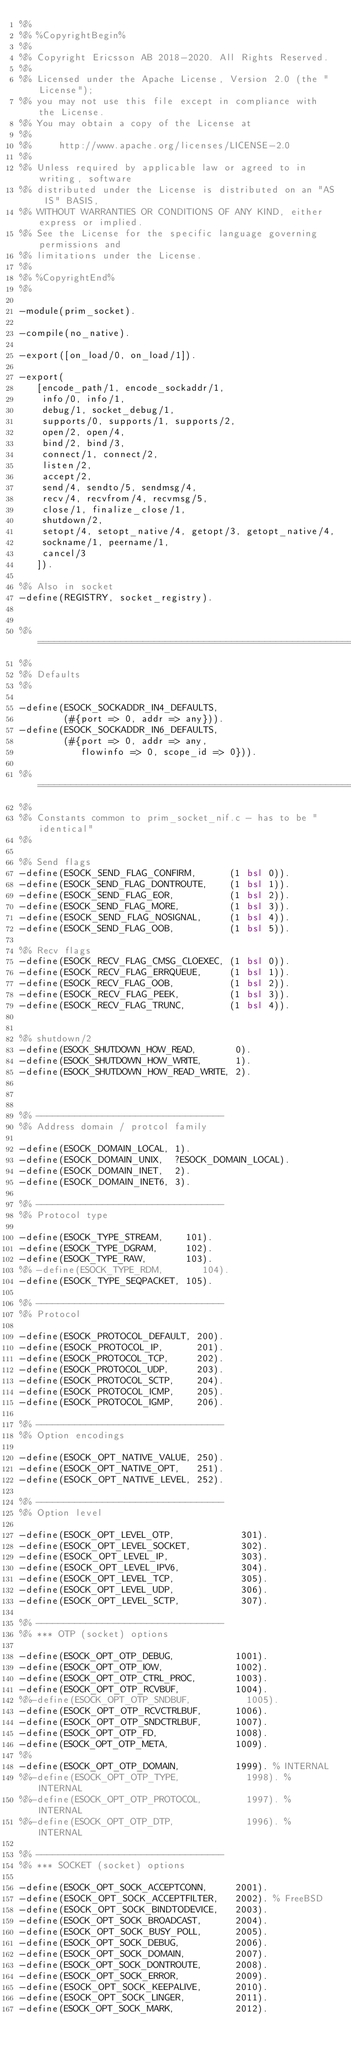Convert code to text. <code><loc_0><loc_0><loc_500><loc_500><_Erlang_>%%
%% %CopyrightBegin%
%%
%% Copyright Ericsson AB 2018-2020. All Rights Reserved.
%%
%% Licensed under the Apache License, Version 2.0 (the "License");
%% you may not use this file except in compliance with the License.
%% You may obtain a copy of the License at
%%
%%     http://www.apache.org/licenses/LICENSE-2.0
%%
%% Unless required by applicable law or agreed to in writing, software
%% distributed under the License is distributed on an "AS IS" BASIS,
%% WITHOUT WARRANTIES OR CONDITIONS OF ANY KIND, either express or implied.
%% See the License for the specific language governing permissions and
%% limitations under the License.
%%
%% %CopyrightEnd%
%%

-module(prim_socket).

-compile(no_native).

-export([on_load/0, on_load/1]).

-export(
   [encode_path/1, encode_sockaddr/1,
    info/0, info/1,
    debug/1, socket_debug/1,
    supports/0, supports/1, supports/2,
    open/2, open/4,
    bind/2, bind/3,
    connect/1, connect/2,
    listen/2,
    accept/2,
    send/4, sendto/5, sendmsg/4,
    recv/4, recvfrom/4, recvmsg/5,
    close/1, finalize_close/1,
    shutdown/2,
    setopt/4, setopt_native/4, getopt/3, getopt_native/4,
    sockname/1, peername/1,
    cancel/3
   ]).

%% Also in socket
-define(REGISTRY, socket_registry).


%% ===========================================================================
%%
%% Defaults
%%

-define(ESOCK_SOCKADDR_IN4_DEFAULTS,
        (#{port => 0, addr => any})).
-define(ESOCK_SOCKADDR_IN6_DEFAULTS,
        (#{port => 0, addr => any,
           flowinfo => 0, scope_id => 0})).

%% ===========================================================================
%%
%% Constants common to prim_socket_nif.c - has to be "identical"
%%

%% Send flags
-define(ESOCK_SEND_FLAG_CONFIRM,      (1 bsl 0)).
-define(ESOCK_SEND_FLAG_DONTROUTE,    (1 bsl 1)).
-define(ESOCK_SEND_FLAG_EOR,          (1 bsl 2)).
-define(ESOCK_SEND_FLAG_MORE,         (1 bsl 3)).
-define(ESOCK_SEND_FLAG_NOSIGNAL,     (1 bsl 4)).
-define(ESOCK_SEND_FLAG_OOB,          (1 bsl 5)).

%% Recv flags
-define(ESOCK_RECV_FLAG_CMSG_CLOEXEC, (1 bsl 0)).
-define(ESOCK_RECV_FLAG_ERRQUEUE,     (1 bsl 1)).
-define(ESOCK_RECV_FLAG_OOB,          (1 bsl 2)).
-define(ESOCK_RECV_FLAG_PEEK,         (1 bsl 3)).
-define(ESOCK_RECV_FLAG_TRUNC,        (1 bsl 4)).


%% shutdown/2
-define(ESOCK_SHUTDOWN_HOW_READ,       0).
-define(ESOCK_SHUTDOWN_HOW_WRITE,      1).
-define(ESOCK_SHUTDOWN_HOW_READ_WRITE, 2).



%% ----------------------------------
%% Address domain / protcol family

-define(ESOCK_DOMAIN_LOCAL, 1).
-define(ESOCK_DOMAIN_UNIX,  ?ESOCK_DOMAIN_LOCAL).
-define(ESOCK_DOMAIN_INET,  2).
-define(ESOCK_DOMAIN_INET6, 3).

%% ----------------------------------
%% Protocol type

-define(ESOCK_TYPE_STREAM,    101).
-define(ESOCK_TYPE_DGRAM,     102).
-define(ESOCK_TYPE_RAW,       103).
%% -define(ESOCK_TYPE_RDM,       104).
-define(ESOCK_TYPE_SEQPACKET, 105).

%% ----------------------------------
%% Protocol

-define(ESOCK_PROTOCOL_DEFAULT, 200).
-define(ESOCK_PROTOCOL_IP,      201).
-define(ESOCK_PROTOCOL_TCP,     202).
-define(ESOCK_PROTOCOL_UDP,     203).
-define(ESOCK_PROTOCOL_SCTP,    204).
-define(ESOCK_PROTOCOL_ICMP,    205).
-define(ESOCK_PROTOCOL_IGMP,    206).

%% ----------------------------------
%% Option encodings

-define(ESOCK_OPT_NATIVE_VALUE, 250).
-define(ESOCK_OPT_NATIVE_OPT,   251).
-define(ESOCK_OPT_NATIVE_LEVEL, 252).

%% ----------------------------------
%% Option level

-define(ESOCK_OPT_LEVEL_OTP,            301).
-define(ESOCK_OPT_LEVEL_SOCKET,         302).
-define(ESOCK_OPT_LEVEL_IP,             303).
-define(ESOCK_OPT_LEVEL_IPV6,           304).
-define(ESOCK_OPT_LEVEL_TCP,            305).
-define(ESOCK_OPT_LEVEL_UDP,            306).
-define(ESOCK_OPT_LEVEL_SCTP,           307).

%% ----------------------------------
%% *** OTP (socket) options

-define(ESOCK_OPT_OTP_DEBUG,           1001).
-define(ESOCK_OPT_OTP_IOW,             1002).
-define(ESOCK_OPT_OTP_CTRL_PROC,       1003).
-define(ESOCK_OPT_OTP_RCVBUF,          1004).
%%-define(ESOCK_OPT_OTP_SNDBUF,          1005).
-define(ESOCK_OPT_OTP_RCVCTRLBUF,      1006).
-define(ESOCK_OPT_OTP_SNDCTRLBUF,      1007).
-define(ESOCK_OPT_OTP_FD,              1008).
-define(ESOCK_OPT_OTP_META,            1009).
%%
-define(ESOCK_OPT_OTP_DOMAIN,          1999). % INTERNAL
%%-define(ESOCK_OPT_OTP_TYPE,            1998). % INTERNAL
%%-define(ESOCK_OPT_OTP_PROTOCOL,        1997). % INTERNAL
%%-define(ESOCK_OPT_OTP_DTP,             1996). % INTERNAL

%% ----------------------------------
%% *** SOCKET (socket) options

-define(ESOCK_OPT_SOCK_ACCEPTCONN,     2001).
-define(ESOCK_OPT_SOCK_ACCEPTFILTER,   2002). % FreeBSD
-define(ESOCK_OPT_SOCK_BINDTODEVICE,   2003).
-define(ESOCK_OPT_SOCK_BROADCAST,      2004).
-define(ESOCK_OPT_SOCK_BUSY_POLL,      2005).
-define(ESOCK_OPT_SOCK_DEBUG,          2006).
-define(ESOCK_OPT_SOCK_DOMAIN,         2007).
-define(ESOCK_OPT_SOCK_DONTROUTE,      2008).
-define(ESOCK_OPT_SOCK_ERROR,          2009).
-define(ESOCK_OPT_SOCK_KEEPALIVE,      2010).
-define(ESOCK_OPT_SOCK_LINGER,         2011).
-define(ESOCK_OPT_SOCK_MARK,           2012).</code> 